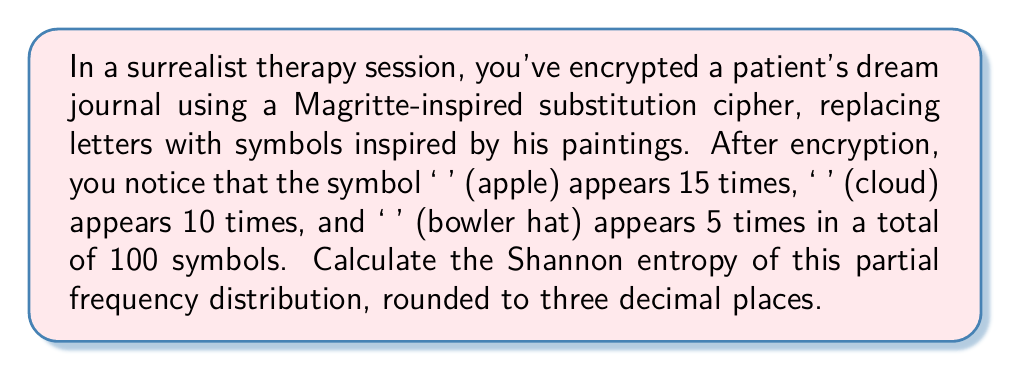Solve this math problem. To calculate the Shannon entropy of this partial frequency distribution, we'll follow these steps:

1) The Shannon entropy is given by the formula:

   $$H = -\sum_{i=1}^n p_i \log_2(p_i)$$

   where $p_i$ is the probability of each symbol.

2) Calculate the probabilities:
   - P(🍎) = 15/100 = 0.15
   - P(☁️) = 10/100 = 0.10
   - P(👒) = 5/100 = 0.05

3) Calculate each term of the sum:
   - For 🍎: $-0.15 \log_2(0.15) = 0.15 \times 2.737 = 0.41055$
   - For ☁️: $-0.10 \log_2(0.10) = 0.10 \times 3.322 = 0.3322$
   - For 👒: $-0.05 \log_2(0.05) = 0.05 \times 4.322 = 0.2161$

4) Sum the terms:
   $$H = 0.41055 + 0.3322 + 0.2161 = 0.95885$$

5) Round to three decimal places: 0.959

Note that this is a partial entropy calculation, as we don't have information about the remaining 70 symbols in the 100-symbol text.
Answer: 0.959 